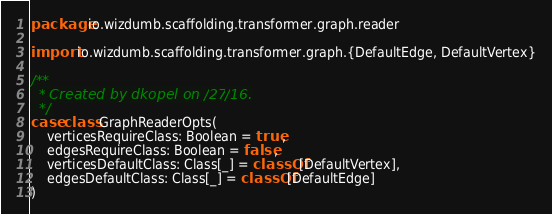<code> <loc_0><loc_0><loc_500><loc_500><_Scala_>package io.wizdumb.scaffolding.transformer.graph.reader

import io.wizdumb.scaffolding.transformer.graph.{DefaultEdge, DefaultVertex}

/**
  * Created by dkopel on 10/27/16.
  */
case class GraphReaderOpts(
    verticesRequireClass: Boolean = true,
    edgesRequireClass: Boolean = false,
    verticesDefaultClass: Class[_] = classOf[DefaultVertex],
    edgesDefaultClass: Class[_] = classOf[DefaultEdge]
)</code> 